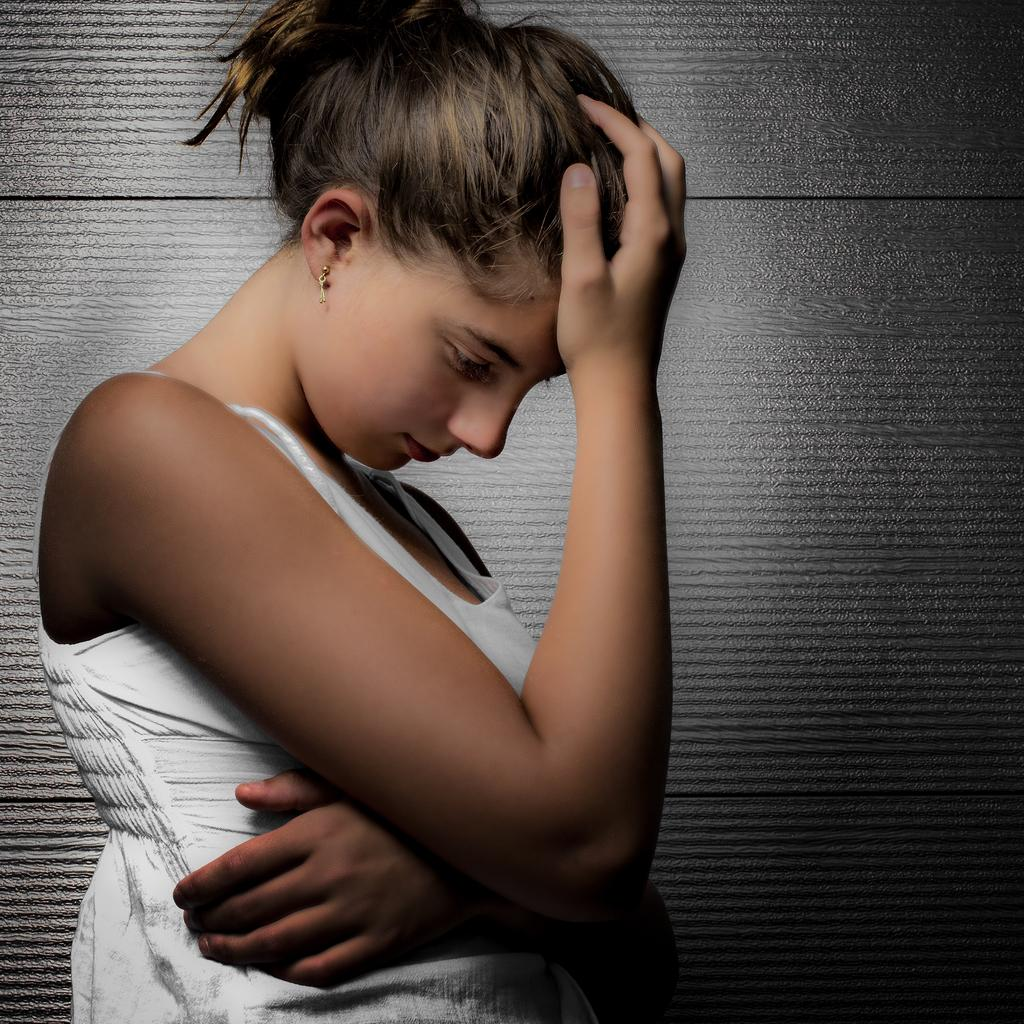Who is the main subject in the image? There is a woman in the image. What is the woman wearing? The woman is wearing a white dress. What is the woman doing with her hand in the image? The woman has her hand on her head. What can be seen in the background of the image? There is an ash-colored wall in the background of the image. What type of quilt is the woman holding in the image? There is no quilt present in the image; the woman has her hand on her head. Can you see a frog on the woman's shoulder in the image? There is no frog visible in the image; the focus is on the woman's white dress and her hand on her head. 